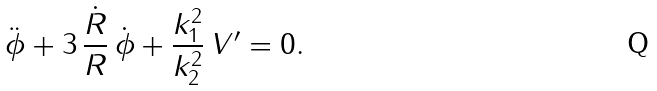Convert formula to latex. <formula><loc_0><loc_0><loc_500><loc_500>\ddot { \phi } + 3 \, { \frac { \dot { R } } { R } } \, \dot { \phi } + { \frac { k _ { 1 } ^ { 2 } } { k _ { 2 } ^ { 2 } } } \, V ^ { \prime } = 0 .</formula> 